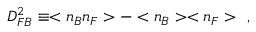Convert formula to latex. <formula><loc_0><loc_0><loc_500><loc_500>D _ { F B } ^ { 2 } \equiv < n _ { B } n _ { F } > - < n _ { B } > < n _ { F } > \ \ ,</formula> 